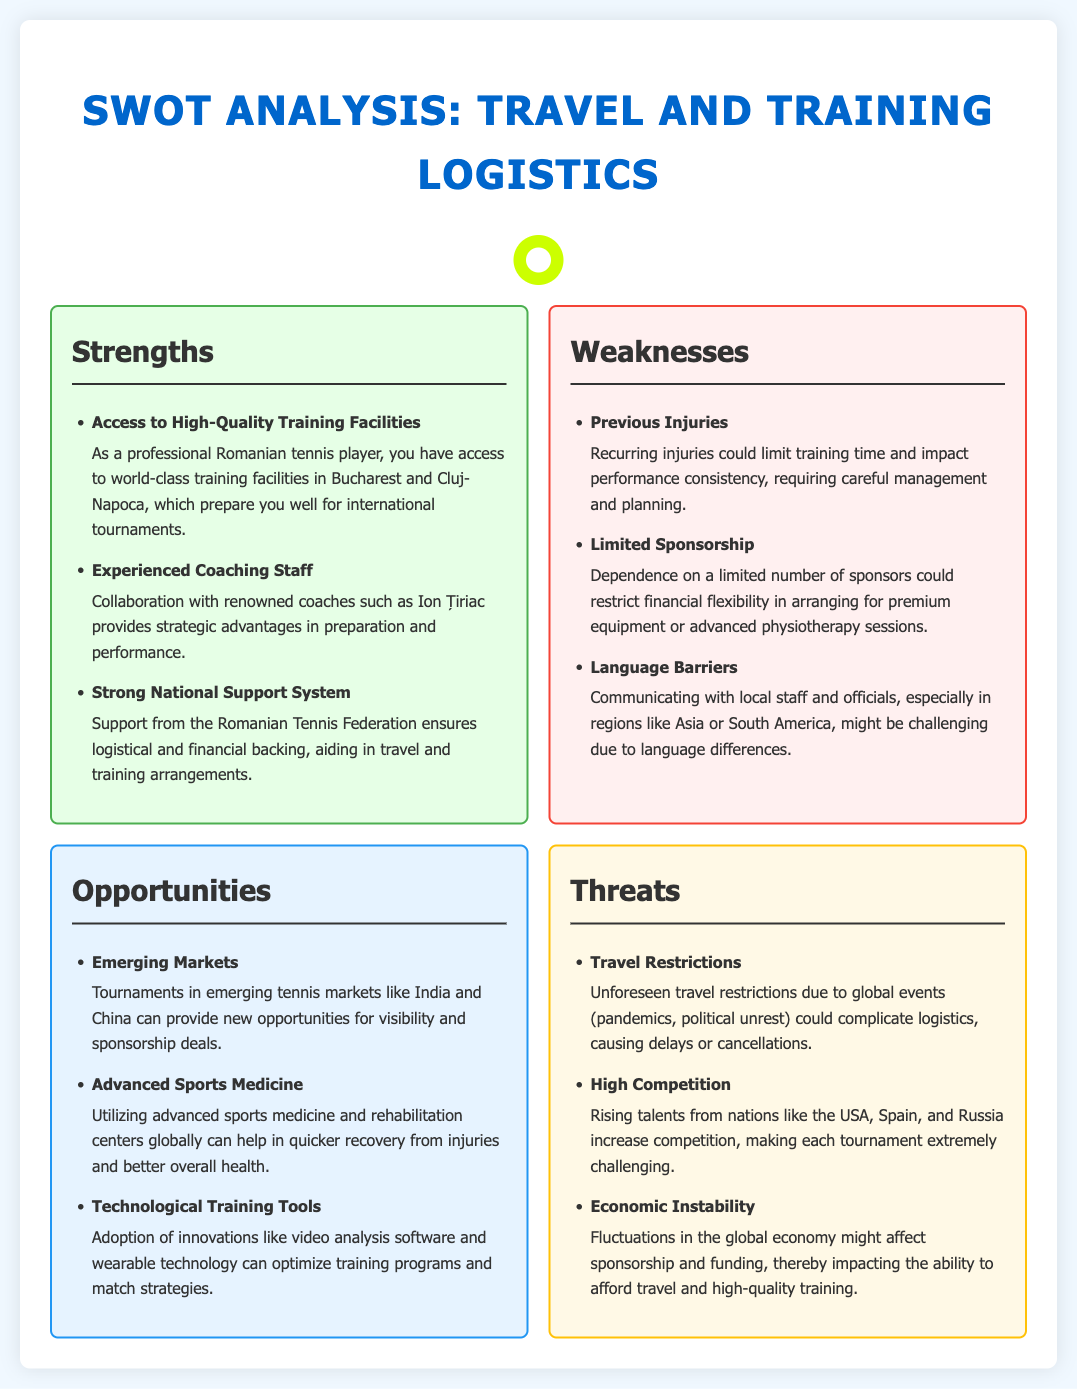What are the strengths mentioned in the analysis? The document lists several strengths in the SWOT analysis section, including access to training facilities, coaching staff, and national support.
Answer: Access to High-Quality Training Facilities, Experienced Coaching Staff, Strong National Support System How many weaknesses are identified in the SWOT analysis? By counting the items listed in the weaknesses section of the document, we find that there are three identified weaknesses.
Answer: 3 What advanced opportunities does the analysis mention? The document lists three specific opportunities related to emerging markets, sports medicine, and training tools.
Answer: Emerging Markets, Advanced Sports Medicine, Technological Training Tools Which individual is noted for their role in coaching? The document specifically mentions Ion Țiriac as a renowned coach providing strategic advantages.
Answer: Ion Țiriac What is a threat related to travel logistics? The analysis highlights travel restrictions as a potential threat affecting logistics for international tournaments.
Answer: Travel Restrictions What impact do emerging tennis markets have? The document explains that emerging markets provide visibility and sponsorship deals as an opportunity for players.
Answer: Provide new opportunities for visibility and sponsorship deals What weakness is associated with previous injuries? The document states that recurring injuries could limit training time and affect performance consistency.
Answer: Limit training time and impact performance consistency How does linguistic diversity affect international competition? The document outlines that language barriers may complicate communication with local staff and officials in various regions.
Answer: Complicate communication with local staff and officials 